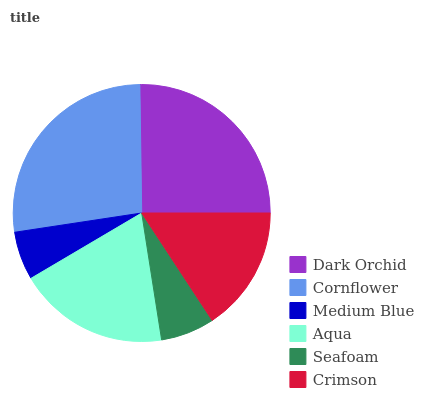Is Medium Blue the minimum?
Answer yes or no. Yes. Is Cornflower the maximum?
Answer yes or no. Yes. Is Cornflower the minimum?
Answer yes or no. No. Is Medium Blue the maximum?
Answer yes or no. No. Is Cornflower greater than Medium Blue?
Answer yes or no. Yes. Is Medium Blue less than Cornflower?
Answer yes or no. Yes. Is Medium Blue greater than Cornflower?
Answer yes or no. No. Is Cornflower less than Medium Blue?
Answer yes or no. No. Is Aqua the high median?
Answer yes or no. Yes. Is Crimson the low median?
Answer yes or no. Yes. Is Medium Blue the high median?
Answer yes or no. No. Is Medium Blue the low median?
Answer yes or no. No. 